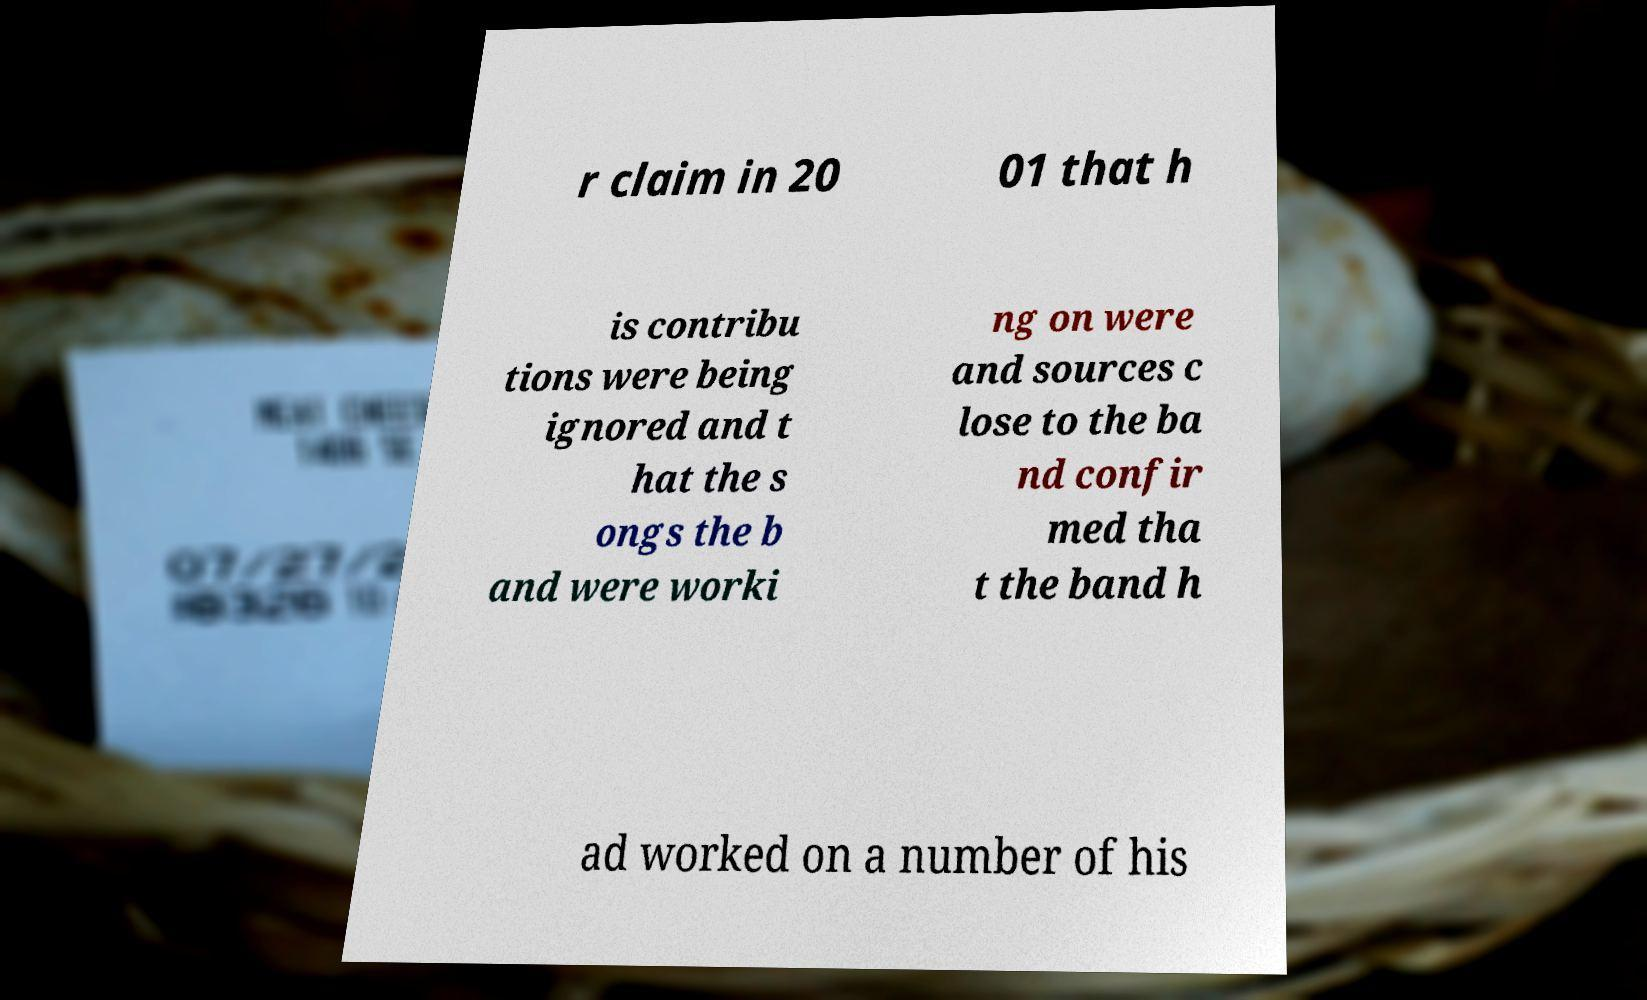Could you assist in decoding the text presented in this image and type it out clearly? r claim in 20 01 that h is contribu tions were being ignored and t hat the s ongs the b and were worki ng on were and sources c lose to the ba nd confir med tha t the band h ad worked on a number of his 